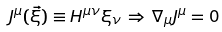<formula> <loc_0><loc_0><loc_500><loc_500>J ^ { \mu } ( \vec { \xi } ) \equiv H ^ { \mu \nu } \xi _ { \nu } \, \Rightarrow \, \nabla _ { \mu } J ^ { \mu } = 0</formula> 